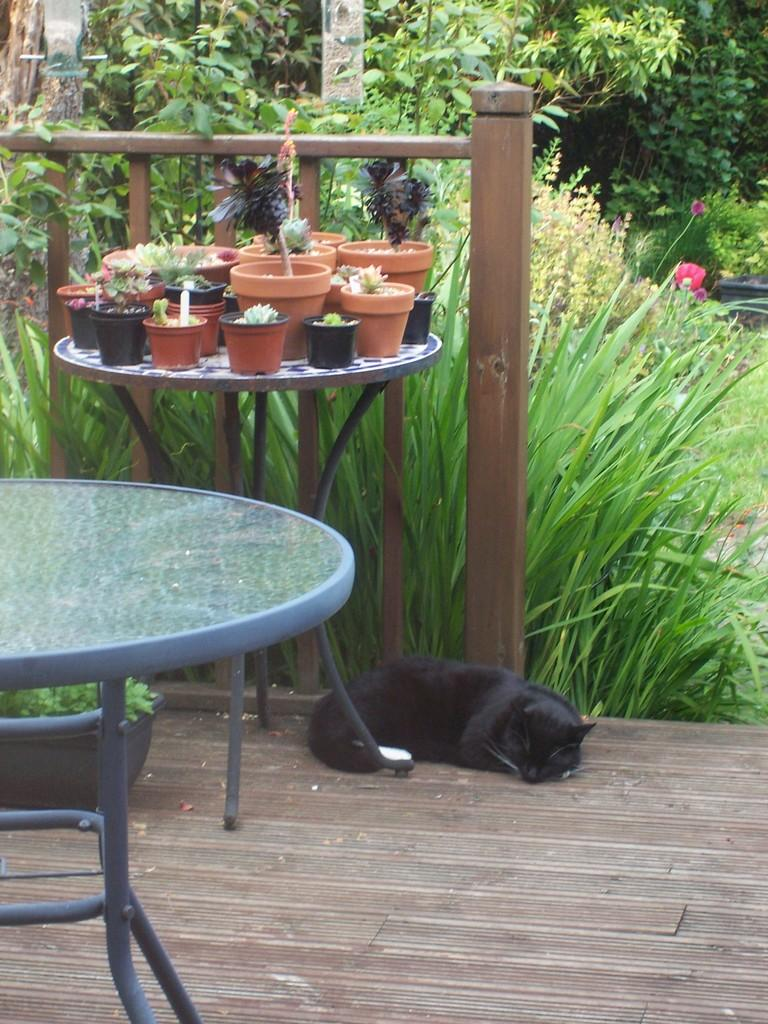What type of animal can be seen in the image? There is an animal in the image, but its specific type is not mentioned in the facts. Where is the animal located in the image? The animal is lying under a table. What other living organisms can be seen in the image? There are plants in the image. What type of ground is visible in the image? There is grass visible in the image. What can be seen in the background of the image? Trees are present in the background of the image. How many copies of the animal's thumb can be seen in the image? There is no mention of a thumb or copies in the image, as it features an animal lying under a table with plants, grass, and trees in the background. 